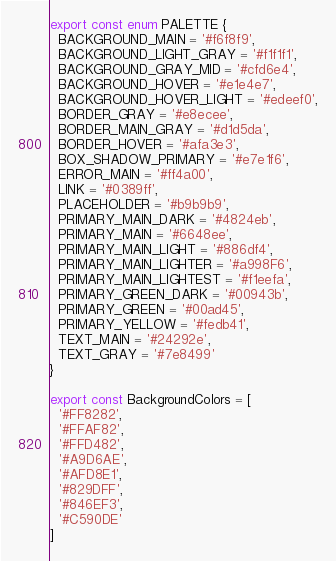<code> <loc_0><loc_0><loc_500><loc_500><_TypeScript_>export const enum PALETTE {
  BACKGROUND_MAIN = '#f6f8f9',
  BACKGROUND_LIGHT_GRAY = '#f1f1f1',
  BACKGROUND_GRAY_MID = '#cfd6e4',
  BACKGROUND_HOVER = '#e1e4e7',
  BACKGROUND_HOVER_LIGHT = '#edeef0',
  BORDER_GRAY = '#e8ecee',
  BORDER_MAIN_GRAY = '#d1d5da',
  BORDER_HOVER = '#afa3e3',
  BOX_SHADOW_PRIMARY = '#e7e1f6',
  ERROR_MAIN = '#ff4a00',
  LINK = '#0389ff',
  PLACEHOLDER = '#b9b9b9',
  PRIMARY_MAIN_DARK = '#4824eb',
  PRIMARY_MAIN = '#6648ee',
  PRIMARY_MAIN_LIGHT = '#886df4',
  PRIMARY_MAIN_LIGHTER = '#a998F6',
  PRIMARY_MAIN_LIGHTEST = '#f1eefa',
  PRIMARY_GREEN_DARK = '#00943b',
  PRIMARY_GREEN = '#00ad45',
  PRIMARY_YELLOW = '#fedb41',
  TEXT_MAIN = '#24292e',
  TEXT_GRAY = '#7e8499'
}

export const BackgroundColors = [
  '#FF8282',
  '#FFAF82',
  '#FFD482',
  '#A9D6AE',
  '#AFD8E1',
  '#829DFF',
  '#846EF3',
  '#C590DE'
]
</code> 